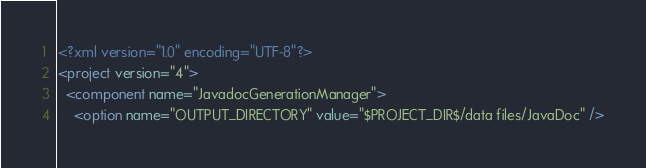<code> <loc_0><loc_0><loc_500><loc_500><_XML_><?xml version="1.0" encoding="UTF-8"?>
<project version="4">
  <component name="JavadocGenerationManager">
    <option name="OUTPUT_DIRECTORY" value="$PROJECT_DIR$/data files/JavaDoc" /></code> 